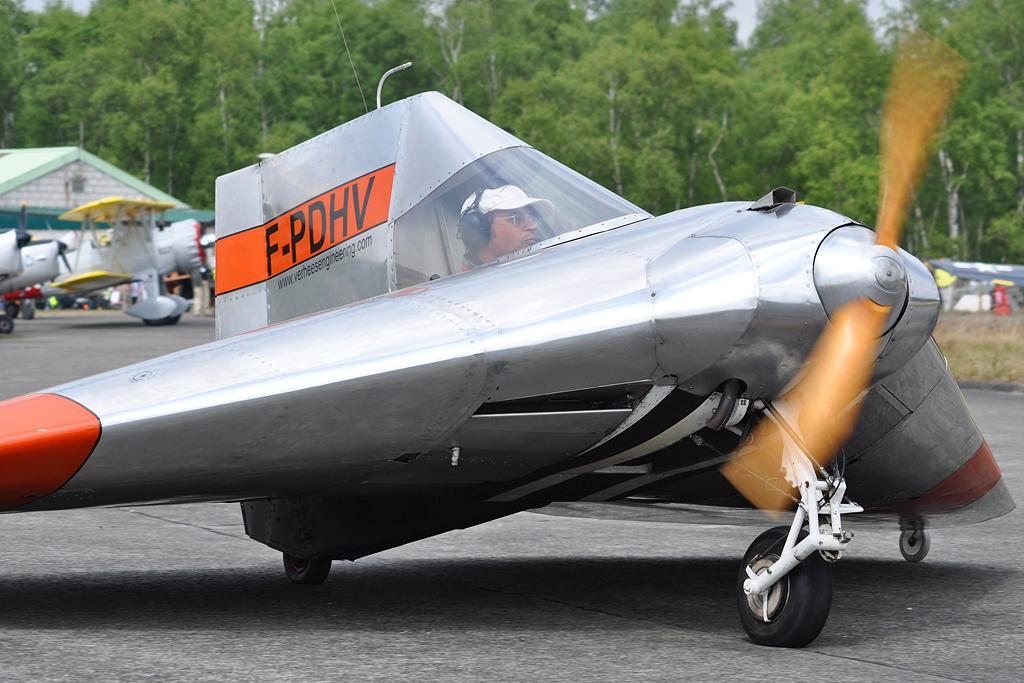<image>
Render a clear and concise summary of the photo. a small silver and red plane labeled F-PDHV 